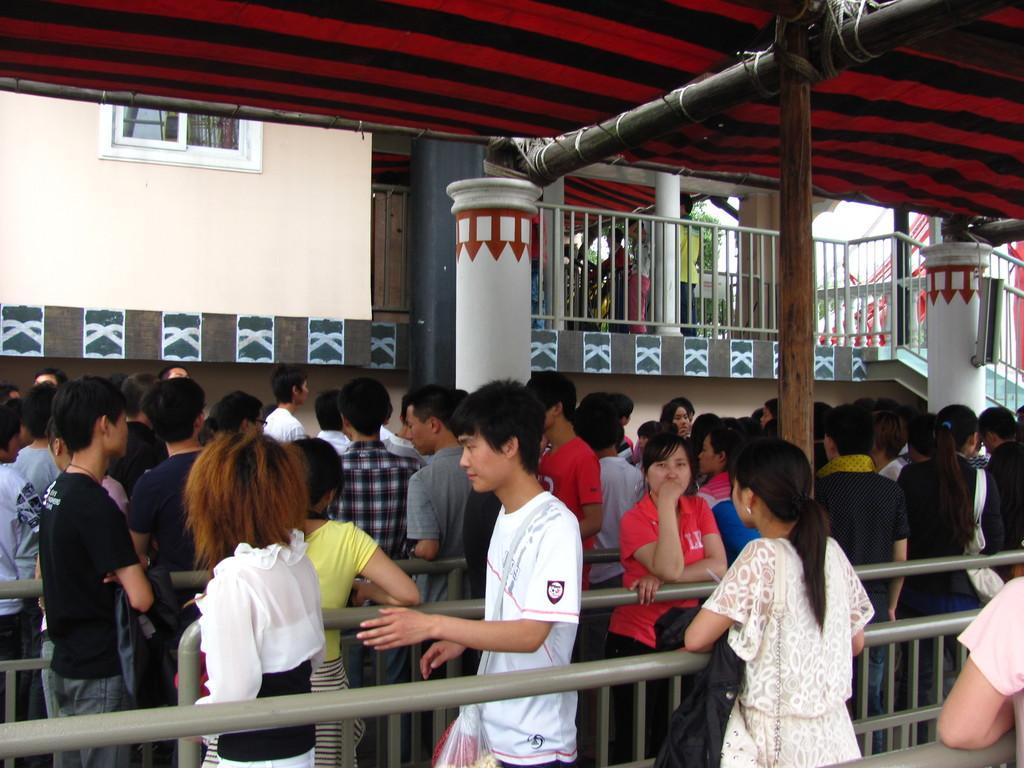Please provide a concise description of this image. This image consists of many people standing in queue. In the middle, there are metal rods. In the background, we can see a building along with the pillars. At the top, there is a tent. 